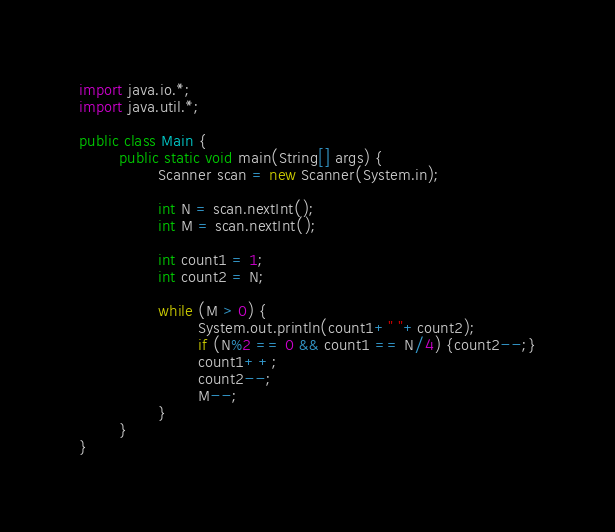Convert code to text. <code><loc_0><loc_0><loc_500><loc_500><_Java_>import java.io.*;
import java.util.*;

public class Main {
        public static void main(String[] args) {
                Scanner scan = new Scanner(System.in);

                int N = scan.nextInt();
                int M = scan.nextInt();

                int count1 = 1;
                int count2 = N;

                while (M > 0) {
                        System.out.println(count1+" "+count2);
                        if (N%2 == 0 && count1 == N/4) {count2--;}
                        count1++;
                        count2--;
                        M--;
                }
        }
}</code> 